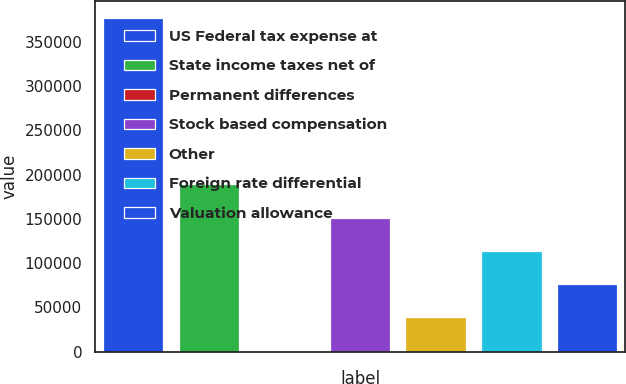Convert chart. <chart><loc_0><loc_0><loc_500><loc_500><bar_chart><fcel>US Federal tax expense at<fcel>State income taxes net of<fcel>Permanent differences<fcel>Stock based compensation<fcel>Other<fcel>Foreign rate differential<fcel>Valuation allowance<nl><fcel>377599<fcel>189276<fcel>954<fcel>151612<fcel>38618.5<fcel>113948<fcel>76283<nl></chart> 